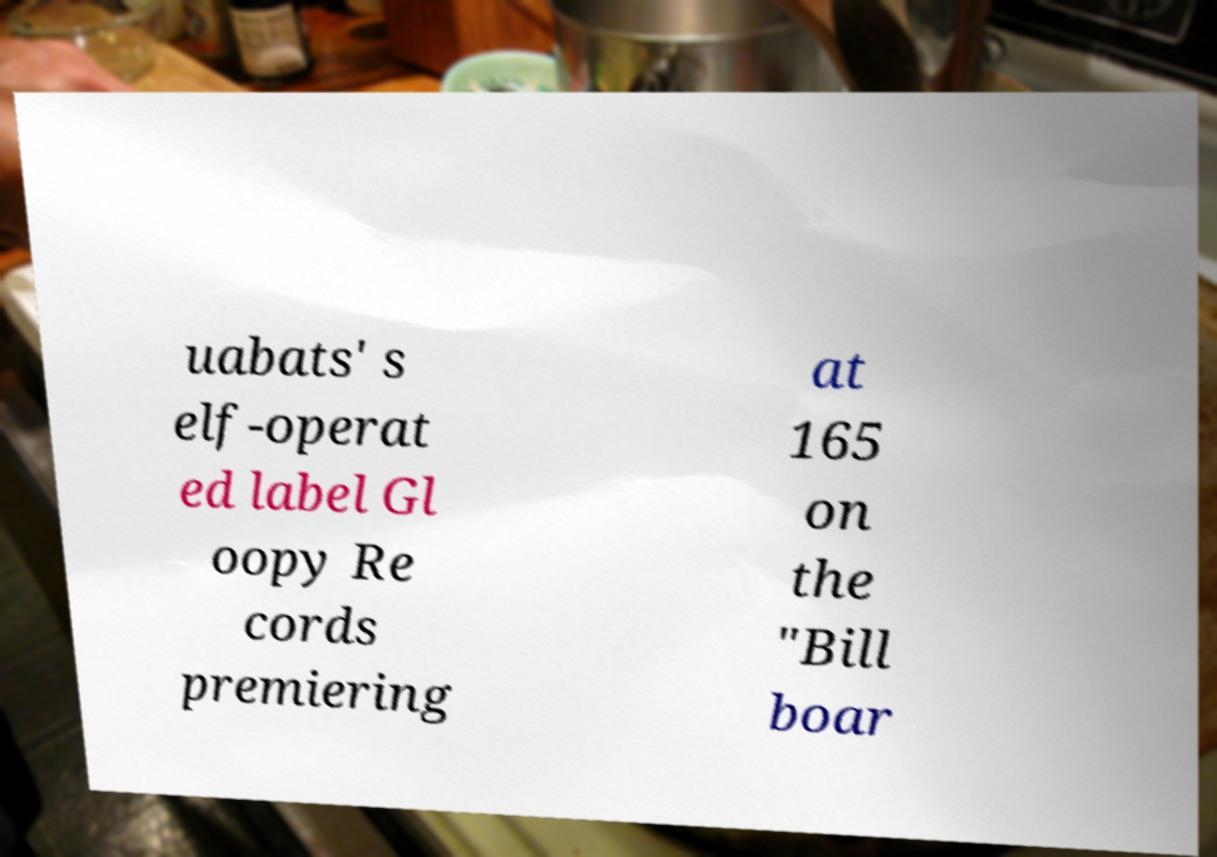Can you read and provide the text displayed in the image?This photo seems to have some interesting text. Can you extract and type it out for me? uabats' s elf-operat ed label Gl oopy Re cords premiering at 165 on the "Bill boar 